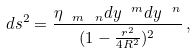<formula> <loc_0><loc_0><loc_500><loc_500>d s ^ { 2 } = \frac { \eta _ { \ m \ n } d y ^ { \ m } d y ^ { \ n } } { ( 1 - \frac { r ^ { 2 } } { 4 R ^ { 2 } } ) ^ { 2 } } \, ,</formula> 